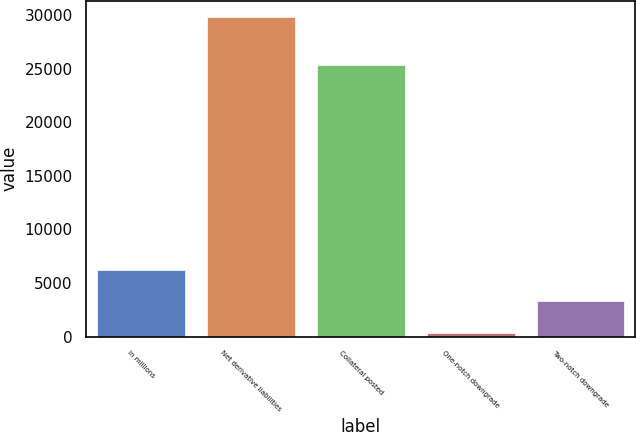Convert chart. <chart><loc_0><loc_0><loc_500><loc_500><bar_chart><fcel>in millions<fcel>Net derivative liabilities<fcel>Collateral posted<fcel>One-notch downgrade<fcel>Two-notch downgrade<nl><fcel>6261.8<fcel>29877<fcel>25329<fcel>358<fcel>3309.9<nl></chart> 